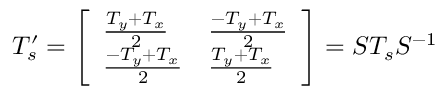<formula> <loc_0><loc_0><loc_500><loc_500>T _ { s } ^ { \prime } = \left [ \begin{array} { l l } { \frac { T _ { y } + T _ { x } } { 2 } } & { \frac { - T _ { y } + T _ { x } } { 2 } } \\ { \frac { - T _ { y } + T _ { x } } { 2 } } & { \frac { T _ { y } + T _ { x } } { 2 } } \end{array} \right ] = S T _ { s } S ^ { - 1 }</formula> 